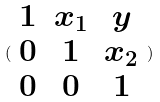<formula> <loc_0><loc_0><loc_500><loc_500>( \begin{array} { c c c } 1 & x _ { 1 } & y \\ 0 & 1 & x _ { 2 } \\ 0 & 0 & 1 \end{array} )</formula> 